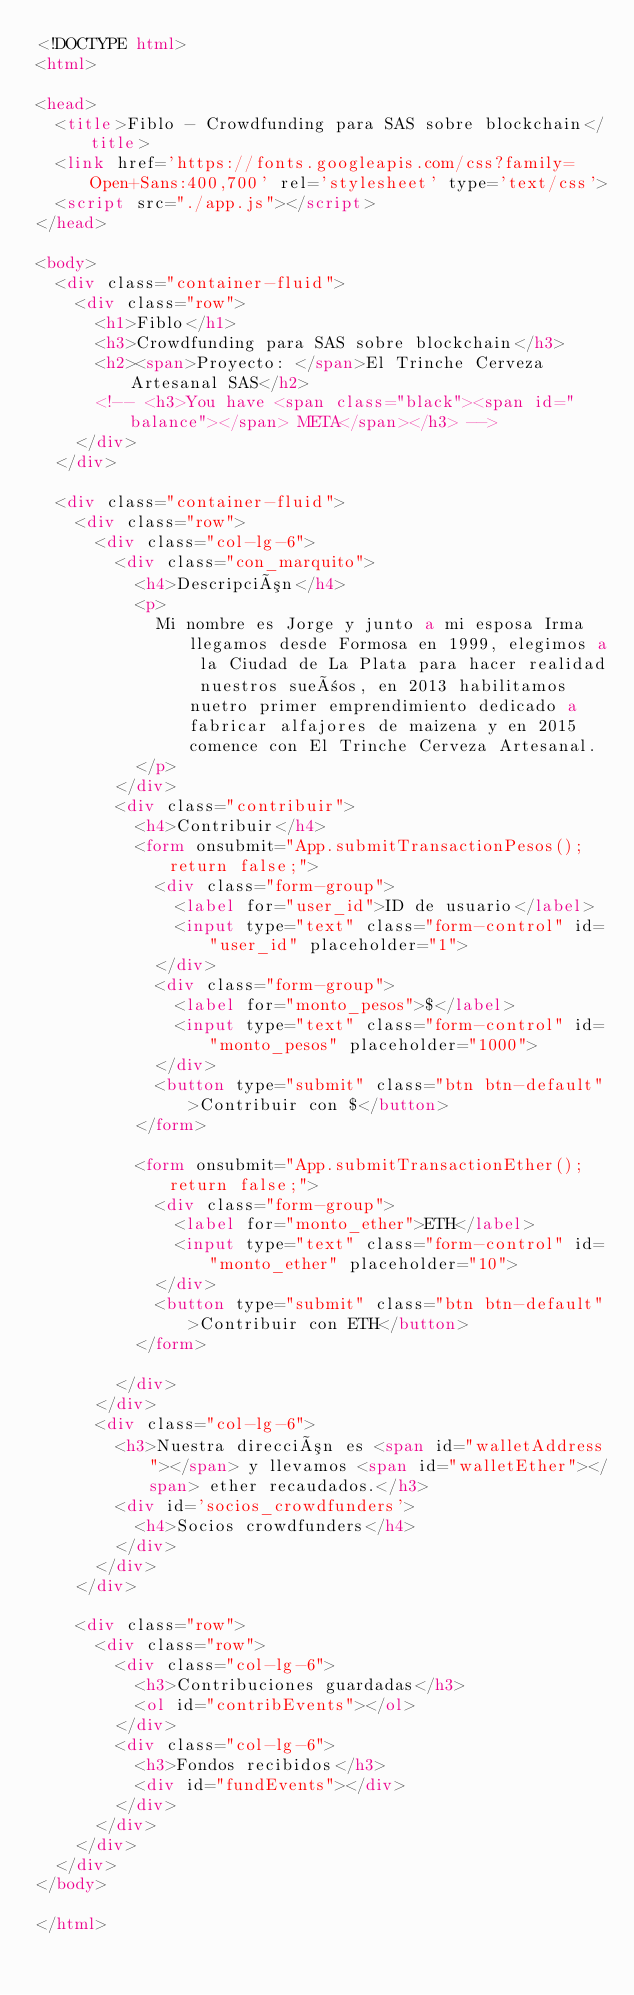Convert code to text. <code><loc_0><loc_0><loc_500><loc_500><_HTML_><!DOCTYPE html>
<html>

<head>
  <title>Fiblo - Crowdfunding para SAS sobre blockchain</title>
  <link href='https://fonts.googleapis.com/css?family=Open+Sans:400,700' rel='stylesheet' type='text/css'>
  <script src="./app.js"></script>
</head>

<body>
  <div class="container-fluid">
    <div class="row">
      <h1>Fiblo</h1>
      <h3>Crowdfunding para SAS sobre blockchain</h3>
      <h2><span>Proyecto: </span>El Trinche Cerveza Artesanal SAS</h2>
      <!-- <h3>You have <span class="black"><span id="balance"></span> META</span></h3> -->
    </div>
  </div>

  <div class="container-fluid">
    <div class="row">
      <div class="col-lg-6">
        <div class="con_marquito">
          <h4>Descripción</h4>
          <p>
            Mi nombre es Jorge y junto a mi esposa Irma llegamos desde Formosa en 1999, elegimos a la Ciudad de La Plata para hacer realidad nuestros sueños, en 2013 habilitamos nuetro primer emprendimiento dedicado a fabricar alfajores de maizena y en 2015 comence con El Trinche Cerveza Artesanal.
          </p>
        </div>
        <div class="contribuir">
          <h4>Contribuir</h4>
          <form onsubmit="App.submitTransactionPesos(); return false;">
            <div class="form-group">
              <label for="user_id">ID de usuario</label>
              <input type="text" class="form-control" id="user_id" placeholder="1">
            </div>
            <div class="form-group">
              <label for="monto_pesos">$</label>
              <input type="text" class="form-control" id="monto_pesos" placeholder="1000">
            </div>
            <button type="submit" class="btn btn-default">Contribuir con $</button>
          </form>

          <form onsubmit="App.submitTransactionEther(); return false;">
            <div class="form-group">
              <label for="monto_ether">ETH</label>
              <input type="text" class="form-control" id="monto_ether" placeholder="10">
            </div>
            <button type="submit" class="btn btn-default">Contribuir con ETH</button>
          </form>

        </div>
      </div>
      <div class="col-lg-6">
        <h3>Nuestra dirección es <span id="walletAddress"></span> y llevamos <span id="walletEther"></span> ether recaudados.</h3>
        <div id='socios_crowdfunders'>
          <h4>Socios crowdfunders</h4>
        </div>
      </div>
    </div>

    <div class="row">
      <div class="row">
        <div class="col-lg-6">
          <h3>Contribuciones guardadas</h3>
          <ol id="contribEvents"></ol>
        </div>
        <div class="col-lg-6">
          <h3>Fondos recibidos</h3>
          <div id="fundEvents"></div>
        </div>
      </div>
    </div>
  </div>
</body>

</html>
</code> 